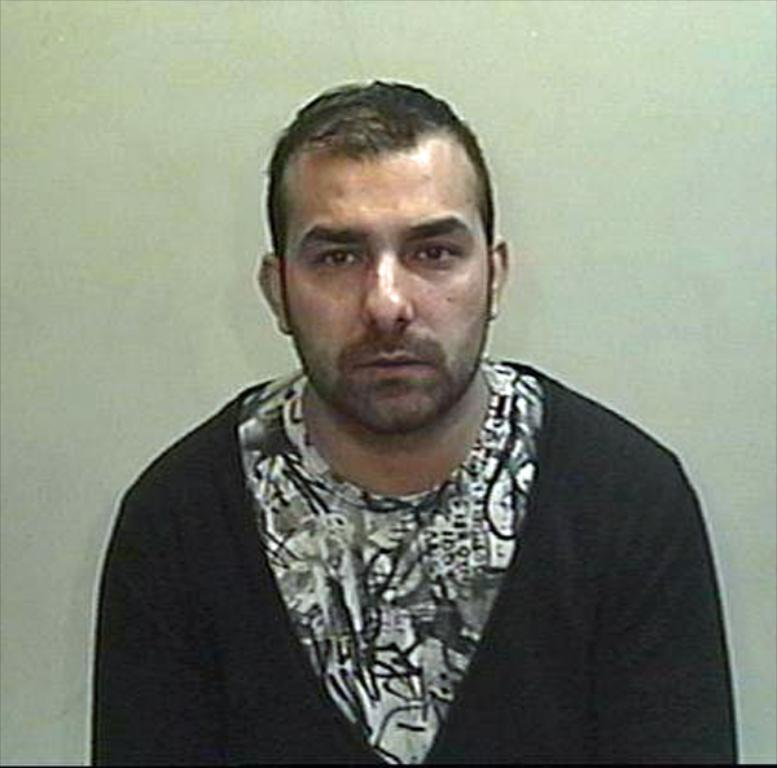Who is present in the image? There is a man in the image. What can be seen behind the man? There is a wall visible in the image. What type of magic trick is the man performing in the image? There is no indication of a magic trick or any magical elements in the image. 